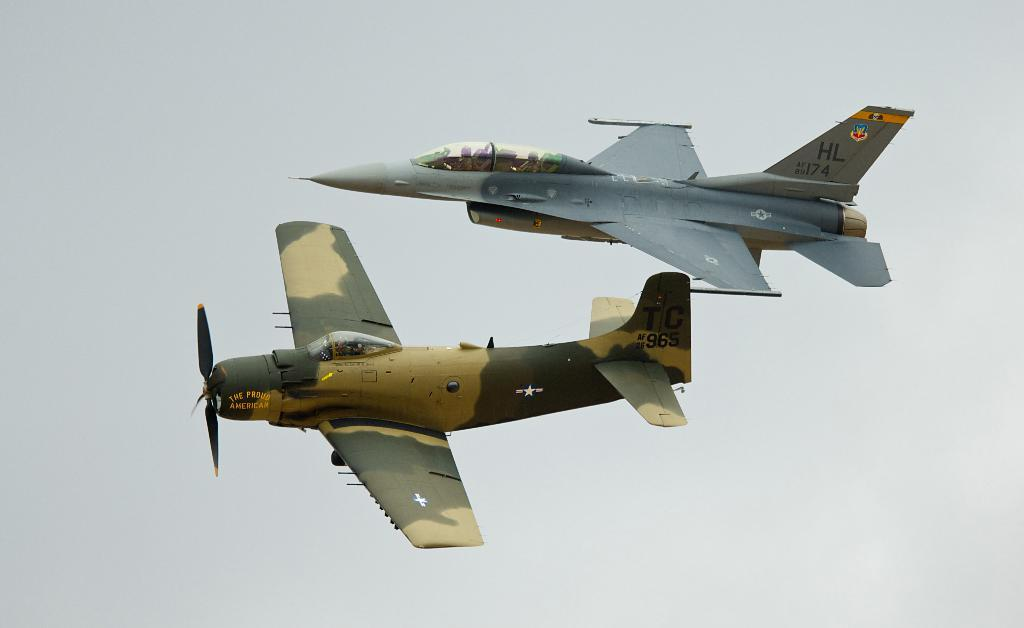Provide a one-sentence caption for the provided image. Two military aircraft with call letters barely visible fly very close to one another. 